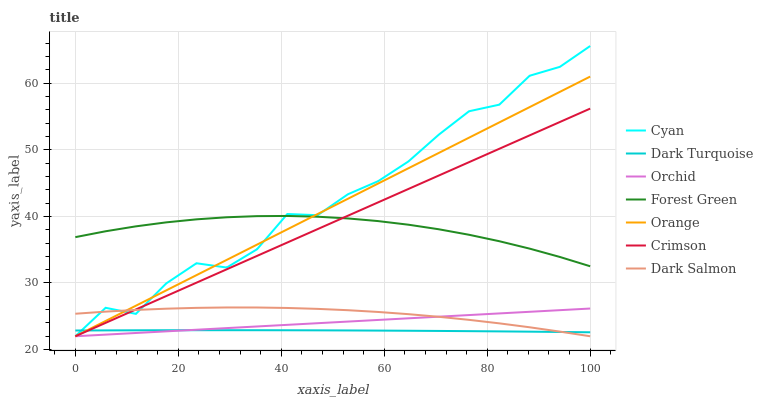Does Dark Turquoise have the minimum area under the curve?
Answer yes or no. Yes. Does Cyan have the maximum area under the curve?
Answer yes or no. Yes. Does Dark Salmon have the minimum area under the curve?
Answer yes or no. No. Does Dark Salmon have the maximum area under the curve?
Answer yes or no. No. Is Orange the smoothest?
Answer yes or no. Yes. Is Cyan the roughest?
Answer yes or no. Yes. Is Dark Salmon the smoothest?
Answer yes or no. No. Is Dark Salmon the roughest?
Answer yes or no. No. Does Dark Salmon have the lowest value?
Answer yes or no. Yes. Does Forest Green have the lowest value?
Answer yes or no. No. Does Cyan have the highest value?
Answer yes or no. Yes. Does Dark Salmon have the highest value?
Answer yes or no. No. Is Orchid less than Forest Green?
Answer yes or no. Yes. Is Forest Green greater than Orchid?
Answer yes or no. Yes. Does Cyan intersect Forest Green?
Answer yes or no. Yes. Is Cyan less than Forest Green?
Answer yes or no. No. Is Cyan greater than Forest Green?
Answer yes or no. No. Does Orchid intersect Forest Green?
Answer yes or no. No. 